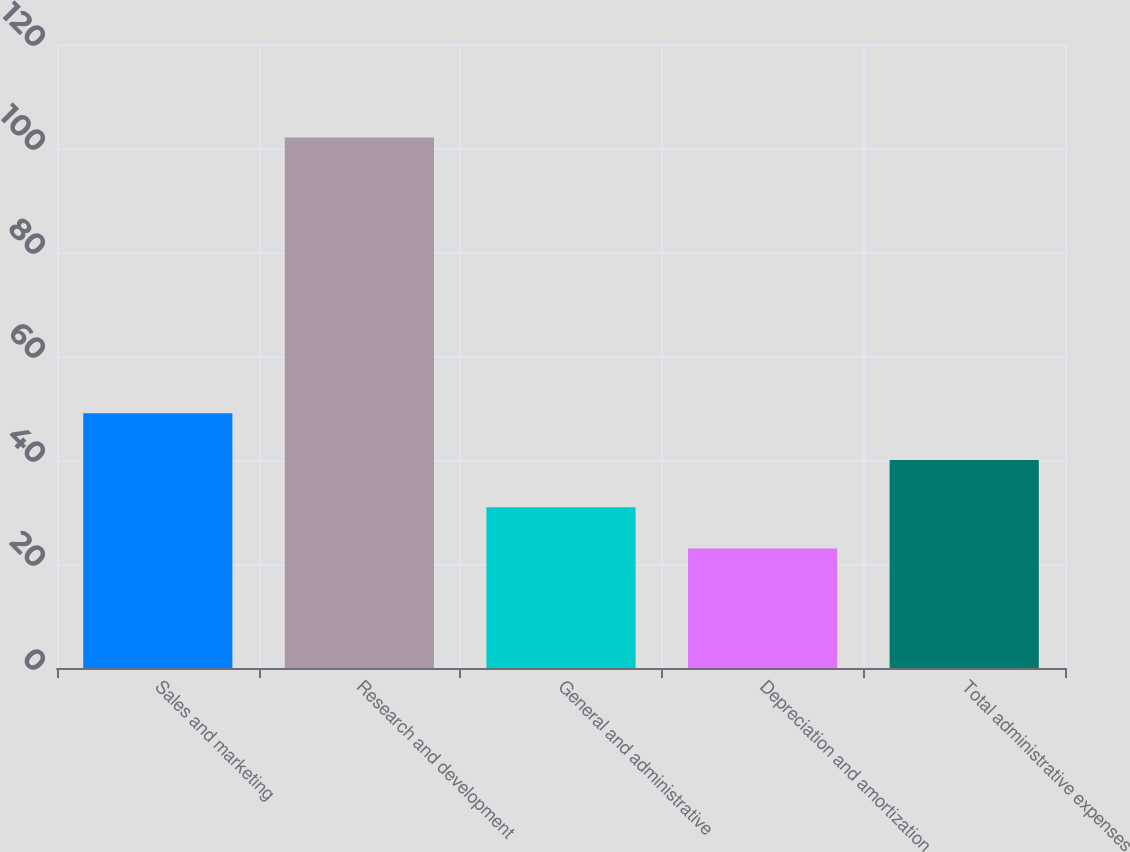<chart> <loc_0><loc_0><loc_500><loc_500><bar_chart><fcel>Sales and marketing<fcel>Research and development<fcel>General and administrative<fcel>Depreciation and amortization<fcel>Total administrative expenses<nl><fcel>49<fcel>102<fcel>30.9<fcel>23<fcel>40<nl></chart> 